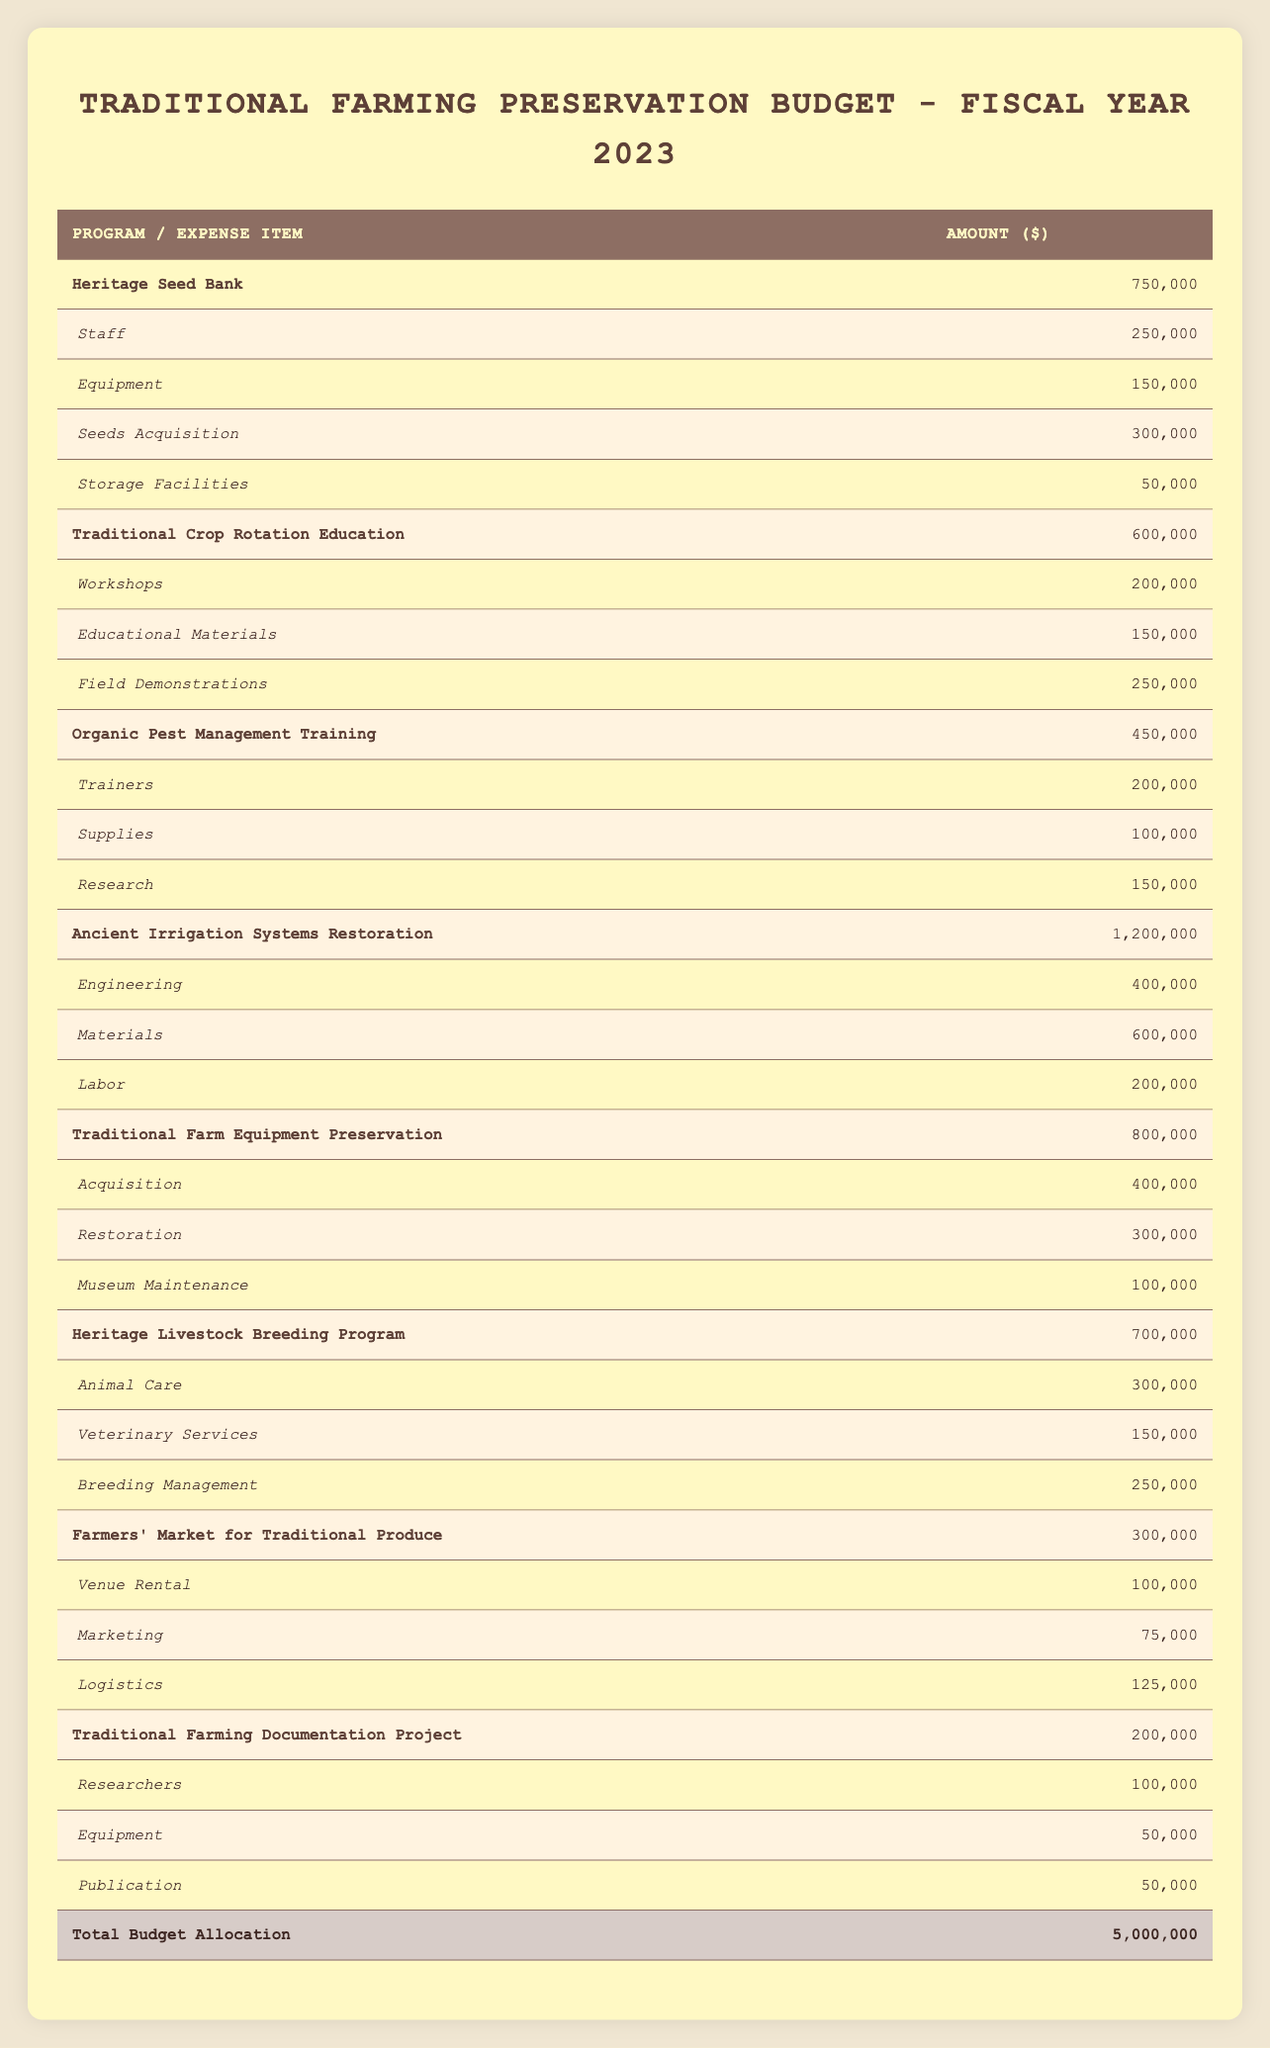What is the total allocation for the "Ancient Irrigation Systems Restoration" program? The allocation for the "Ancient Irrigation Systems Restoration" program is listed in the table as 1,200,000.
Answer: 1,200,000 What are the expenses for "Heritage Seed Bank"? The expenses for the "Heritage Seed Bank" program are: Staff 250,000, Equipment 150,000, Seeds Acquisition 300,000, Storage Facilities 50,000.
Answer: Staff 250,000, Equipment 150,000, Seeds Acquisition 300,000, Storage Facilities 50,000 What is the sum of all allocations for preservation programs? The total budget allocation for all programs is provided at the bottom of the table as 5,000,000.
Answer: 5,000,000 Does "Traditional Farming Documentation Project" have a higher allocation than "Farmers' Market for Traditional Produce"? The allocation for the "Traditional Farming Documentation Project" is 200,000, while "Farmers' Market for Traditional Produce" has an allocation of 300,000, so the statement is false.
Answer: No What percentage of the total budget is allocated to the "Heritage Livestock Breeding Program"? To find the percentage, take the allocation of the program (700,000) and divide it by the total budget (5,000,000) then multiply by 100: (700,000 / 5,000,000) * 100 = 14%.
Answer: 14% What is the total expense for the "Traditional Crop Rotation Education" program? To calculate the total expenses, sum up the expenses listed: Workshops 200,000 + Educational Materials 150,000 + Field Demonstrations 250,000 = 600,000. The total expense matches its allocation.
Answer: 600,000 Is the allocation for "Organic Pest Management Training" the lowest among all programs? Comparing all program allocations, "Organic Pest Management Training" is 450,000, which is higher than the lowest allocation of 200,000 for "Traditional Farming Documentation Project," so the statement is false.
Answer: No What is the combined allocation for "Heritage Seed Bank" and "Organic Pest Management Training"? The allocation for "Heritage Seed Bank" is 750,000 and for "Organic Pest Management Training" is 450,000. Adding these together gives 750,000 + 450,000 = 1,200,000.
Answer: 1,200,000 How much more is allocated to "Ancient Irrigation Systems Restoration" compared to "Heritage Seed Bank"? The allocation for "Ancient Irrigation Systems Restoration" is 1,200,000 and for "Heritage Seed Bank" it is 750,000. The difference is 1,200,000 - 750,000 = 450,000.
Answer: 450,000 